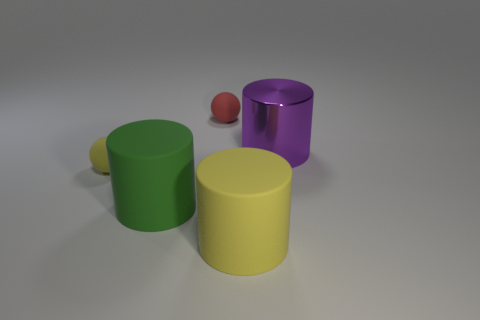Add 2 balls. How many objects exist? 7 Subtract all rubber cylinders. How many cylinders are left? 1 Subtract all yellow cylinders. How many cylinders are left? 2 Subtract 3 cylinders. How many cylinders are left? 0 Subtract all cylinders. How many objects are left? 2 Subtract all yellow rubber cubes. Subtract all purple cylinders. How many objects are left? 4 Add 1 green rubber objects. How many green rubber objects are left? 2 Add 1 large blue shiny blocks. How many large blue shiny blocks exist? 1 Subtract 1 purple cylinders. How many objects are left? 4 Subtract all blue cylinders. Subtract all blue blocks. How many cylinders are left? 3 